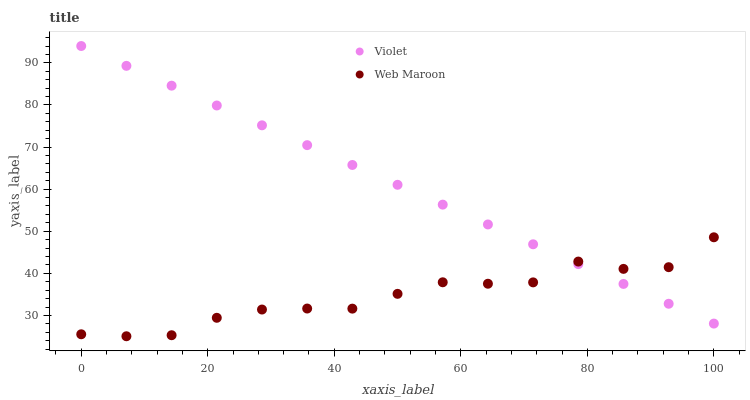Does Web Maroon have the minimum area under the curve?
Answer yes or no. Yes. Does Violet have the maximum area under the curve?
Answer yes or no. Yes. Does Violet have the minimum area under the curve?
Answer yes or no. No. Is Violet the smoothest?
Answer yes or no. Yes. Is Web Maroon the roughest?
Answer yes or no. Yes. Is Violet the roughest?
Answer yes or no. No. Does Web Maroon have the lowest value?
Answer yes or no. Yes. Does Violet have the lowest value?
Answer yes or no. No. Does Violet have the highest value?
Answer yes or no. Yes. Does Violet intersect Web Maroon?
Answer yes or no. Yes. Is Violet less than Web Maroon?
Answer yes or no. No. Is Violet greater than Web Maroon?
Answer yes or no. No. 